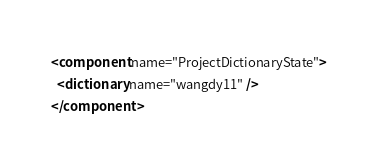Convert code to text. <code><loc_0><loc_0><loc_500><loc_500><_XML_><component name="ProjectDictionaryState">
  <dictionary name="wangdy11" />
</component></code> 